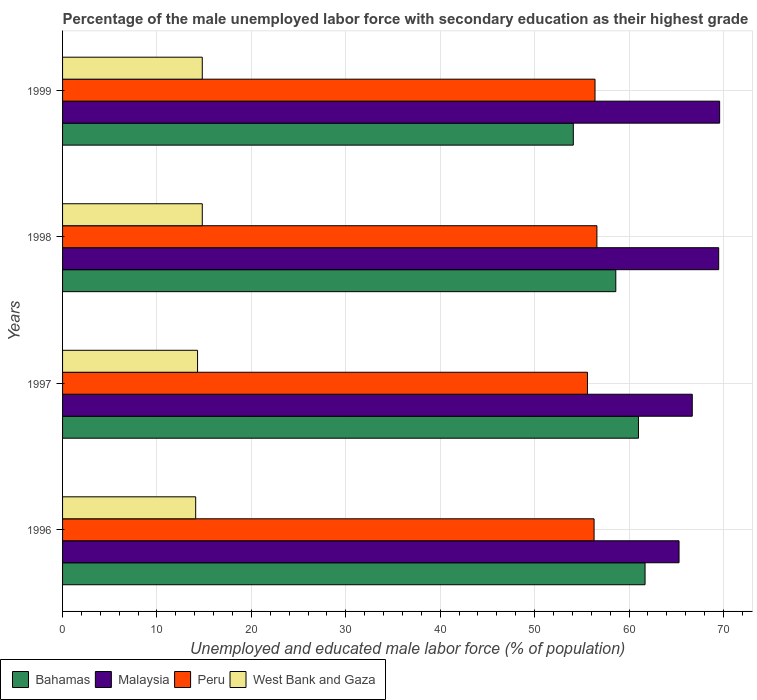How many different coloured bars are there?
Offer a terse response. 4. How many groups of bars are there?
Ensure brevity in your answer.  4. Are the number of bars per tick equal to the number of legend labels?
Your answer should be compact. Yes. Are the number of bars on each tick of the Y-axis equal?
Ensure brevity in your answer.  Yes. What is the label of the 1st group of bars from the top?
Make the answer very short. 1999. What is the percentage of the unemployed male labor force with secondary education in West Bank and Gaza in 1997?
Provide a short and direct response. 14.3. Across all years, what is the maximum percentage of the unemployed male labor force with secondary education in Bahamas?
Give a very brief answer. 61.7. Across all years, what is the minimum percentage of the unemployed male labor force with secondary education in Bahamas?
Keep it short and to the point. 54.1. What is the total percentage of the unemployed male labor force with secondary education in Bahamas in the graph?
Provide a succinct answer. 235.4. What is the difference between the percentage of the unemployed male labor force with secondary education in Malaysia in 1996 and that in 1999?
Your answer should be very brief. -4.3. What is the difference between the percentage of the unemployed male labor force with secondary education in Peru in 1996 and the percentage of the unemployed male labor force with secondary education in Bahamas in 1998?
Offer a very short reply. -2.3. What is the average percentage of the unemployed male labor force with secondary education in Malaysia per year?
Keep it short and to the point. 67.77. In the year 1996, what is the difference between the percentage of the unemployed male labor force with secondary education in Bahamas and percentage of the unemployed male labor force with secondary education in Peru?
Your answer should be very brief. 5.4. In how many years, is the percentage of the unemployed male labor force with secondary education in Malaysia greater than 66 %?
Keep it short and to the point. 3. What is the ratio of the percentage of the unemployed male labor force with secondary education in West Bank and Gaza in 1996 to that in 1998?
Provide a short and direct response. 0.95. Is the difference between the percentage of the unemployed male labor force with secondary education in Bahamas in 1996 and 1999 greater than the difference between the percentage of the unemployed male labor force with secondary education in Peru in 1996 and 1999?
Provide a succinct answer. Yes. What is the difference between the highest and the second highest percentage of the unemployed male labor force with secondary education in Bahamas?
Ensure brevity in your answer.  0.7. What is the difference between the highest and the lowest percentage of the unemployed male labor force with secondary education in Peru?
Offer a terse response. 1. In how many years, is the percentage of the unemployed male labor force with secondary education in Peru greater than the average percentage of the unemployed male labor force with secondary education in Peru taken over all years?
Your answer should be very brief. 3. Is it the case that in every year, the sum of the percentage of the unemployed male labor force with secondary education in Bahamas and percentage of the unemployed male labor force with secondary education in Peru is greater than the sum of percentage of the unemployed male labor force with secondary education in Malaysia and percentage of the unemployed male labor force with secondary education in West Bank and Gaza?
Keep it short and to the point. No. What does the 4th bar from the top in 1996 represents?
Ensure brevity in your answer.  Bahamas. What does the 4th bar from the bottom in 1999 represents?
Make the answer very short. West Bank and Gaza. How many bars are there?
Give a very brief answer. 16. Are all the bars in the graph horizontal?
Keep it short and to the point. Yes. What is the difference between two consecutive major ticks on the X-axis?
Make the answer very short. 10. Does the graph contain grids?
Your response must be concise. Yes. How many legend labels are there?
Give a very brief answer. 4. How are the legend labels stacked?
Provide a succinct answer. Horizontal. What is the title of the graph?
Provide a short and direct response. Percentage of the male unemployed labor force with secondary education as their highest grade. What is the label or title of the X-axis?
Offer a terse response. Unemployed and educated male labor force (% of population). What is the label or title of the Y-axis?
Provide a succinct answer. Years. What is the Unemployed and educated male labor force (% of population) of Bahamas in 1996?
Make the answer very short. 61.7. What is the Unemployed and educated male labor force (% of population) of Malaysia in 1996?
Offer a very short reply. 65.3. What is the Unemployed and educated male labor force (% of population) of Peru in 1996?
Provide a succinct answer. 56.3. What is the Unemployed and educated male labor force (% of population) of West Bank and Gaza in 1996?
Ensure brevity in your answer.  14.1. What is the Unemployed and educated male labor force (% of population) in Malaysia in 1997?
Keep it short and to the point. 66.7. What is the Unemployed and educated male labor force (% of population) of Peru in 1997?
Your answer should be compact. 55.6. What is the Unemployed and educated male labor force (% of population) in West Bank and Gaza in 1997?
Your answer should be compact. 14.3. What is the Unemployed and educated male labor force (% of population) in Bahamas in 1998?
Offer a terse response. 58.6. What is the Unemployed and educated male labor force (% of population) of Malaysia in 1998?
Your answer should be compact. 69.5. What is the Unemployed and educated male labor force (% of population) of Peru in 1998?
Make the answer very short. 56.6. What is the Unemployed and educated male labor force (% of population) of West Bank and Gaza in 1998?
Offer a terse response. 14.8. What is the Unemployed and educated male labor force (% of population) of Bahamas in 1999?
Provide a succinct answer. 54.1. What is the Unemployed and educated male labor force (% of population) of Malaysia in 1999?
Your answer should be compact. 69.6. What is the Unemployed and educated male labor force (% of population) in Peru in 1999?
Your answer should be very brief. 56.4. What is the Unemployed and educated male labor force (% of population) of West Bank and Gaza in 1999?
Your answer should be very brief. 14.8. Across all years, what is the maximum Unemployed and educated male labor force (% of population) of Bahamas?
Offer a very short reply. 61.7. Across all years, what is the maximum Unemployed and educated male labor force (% of population) in Malaysia?
Ensure brevity in your answer.  69.6. Across all years, what is the maximum Unemployed and educated male labor force (% of population) of Peru?
Your answer should be compact. 56.6. Across all years, what is the maximum Unemployed and educated male labor force (% of population) of West Bank and Gaza?
Your answer should be very brief. 14.8. Across all years, what is the minimum Unemployed and educated male labor force (% of population) in Bahamas?
Your answer should be compact. 54.1. Across all years, what is the minimum Unemployed and educated male labor force (% of population) in Malaysia?
Offer a very short reply. 65.3. Across all years, what is the minimum Unemployed and educated male labor force (% of population) of Peru?
Make the answer very short. 55.6. Across all years, what is the minimum Unemployed and educated male labor force (% of population) of West Bank and Gaza?
Keep it short and to the point. 14.1. What is the total Unemployed and educated male labor force (% of population) of Bahamas in the graph?
Your answer should be compact. 235.4. What is the total Unemployed and educated male labor force (% of population) of Malaysia in the graph?
Keep it short and to the point. 271.1. What is the total Unemployed and educated male labor force (% of population) of Peru in the graph?
Give a very brief answer. 224.9. What is the total Unemployed and educated male labor force (% of population) of West Bank and Gaza in the graph?
Your response must be concise. 58. What is the difference between the Unemployed and educated male labor force (% of population) in Bahamas in 1996 and that in 1997?
Provide a short and direct response. 0.7. What is the difference between the Unemployed and educated male labor force (% of population) in Malaysia in 1996 and that in 1997?
Your response must be concise. -1.4. What is the difference between the Unemployed and educated male labor force (% of population) in Peru in 1996 and that in 1997?
Offer a very short reply. 0.7. What is the difference between the Unemployed and educated male labor force (% of population) of West Bank and Gaza in 1996 and that in 1997?
Keep it short and to the point. -0.2. What is the difference between the Unemployed and educated male labor force (% of population) of Peru in 1996 and that in 1998?
Your answer should be compact. -0.3. What is the difference between the Unemployed and educated male labor force (% of population) of Bahamas in 1996 and that in 1999?
Your answer should be very brief. 7.6. What is the difference between the Unemployed and educated male labor force (% of population) of Malaysia in 1996 and that in 1999?
Your answer should be very brief. -4.3. What is the difference between the Unemployed and educated male labor force (% of population) of Malaysia in 1997 and that in 1998?
Your answer should be compact. -2.8. What is the difference between the Unemployed and educated male labor force (% of population) of Peru in 1997 and that in 1999?
Your answer should be very brief. -0.8. What is the difference between the Unemployed and educated male labor force (% of population) in Bahamas in 1998 and that in 1999?
Offer a very short reply. 4.5. What is the difference between the Unemployed and educated male labor force (% of population) of Peru in 1998 and that in 1999?
Provide a succinct answer. 0.2. What is the difference between the Unemployed and educated male labor force (% of population) in West Bank and Gaza in 1998 and that in 1999?
Keep it short and to the point. 0. What is the difference between the Unemployed and educated male labor force (% of population) of Bahamas in 1996 and the Unemployed and educated male labor force (% of population) of Malaysia in 1997?
Offer a very short reply. -5. What is the difference between the Unemployed and educated male labor force (% of population) in Bahamas in 1996 and the Unemployed and educated male labor force (% of population) in Peru in 1997?
Give a very brief answer. 6.1. What is the difference between the Unemployed and educated male labor force (% of population) of Bahamas in 1996 and the Unemployed and educated male labor force (% of population) of West Bank and Gaza in 1997?
Make the answer very short. 47.4. What is the difference between the Unemployed and educated male labor force (% of population) of Malaysia in 1996 and the Unemployed and educated male labor force (% of population) of Peru in 1997?
Provide a short and direct response. 9.7. What is the difference between the Unemployed and educated male labor force (% of population) in Bahamas in 1996 and the Unemployed and educated male labor force (% of population) in Malaysia in 1998?
Your answer should be very brief. -7.8. What is the difference between the Unemployed and educated male labor force (% of population) of Bahamas in 1996 and the Unemployed and educated male labor force (% of population) of Peru in 1998?
Give a very brief answer. 5.1. What is the difference between the Unemployed and educated male labor force (% of population) in Bahamas in 1996 and the Unemployed and educated male labor force (% of population) in West Bank and Gaza in 1998?
Keep it short and to the point. 46.9. What is the difference between the Unemployed and educated male labor force (% of population) in Malaysia in 1996 and the Unemployed and educated male labor force (% of population) in Peru in 1998?
Give a very brief answer. 8.7. What is the difference between the Unemployed and educated male labor force (% of population) of Malaysia in 1996 and the Unemployed and educated male labor force (% of population) of West Bank and Gaza in 1998?
Your answer should be compact. 50.5. What is the difference between the Unemployed and educated male labor force (% of population) of Peru in 1996 and the Unemployed and educated male labor force (% of population) of West Bank and Gaza in 1998?
Keep it short and to the point. 41.5. What is the difference between the Unemployed and educated male labor force (% of population) of Bahamas in 1996 and the Unemployed and educated male labor force (% of population) of Peru in 1999?
Make the answer very short. 5.3. What is the difference between the Unemployed and educated male labor force (% of population) of Bahamas in 1996 and the Unemployed and educated male labor force (% of population) of West Bank and Gaza in 1999?
Keep it short and to the point. 46.9. What is the difference between the Unemployed and educated male labor force (% of population) in Malaysia in 1996 and the Unemployed and educated male labor force (% of population) in West Bank and Gaza in 1999?
Your answer should be compact. 50.5. What is the difference between the Unemployed and educated male labor force (% of population) of Peru in 1996 and the Unemployed and educated male labor force (% of population) of West Bank and Gaza in 1999?
Provide a succinct answer. 41.5. What is the difference between the Unemployed and educated male labor force (% of population) of Bahamas in 1997 and the Unemployed and educated male labor force (% of population) of Peru in 1998?
Ensure brevity in your answer.  4.4. What is the difference between the Unemployed and educated male labor force (% of population) in Bahamas in 1997 and the Unemployed and educated male labor force (% of population) in West Bank and Gaza in 1998?
Provide a short and direct response. 46.2. What is the difference between the Unemployed and educated male labor force (% of population) of Malaysia in 1997 and the Unemployed and educated male labor force (% of population) of Peru in 1998?
Your answer should be compact. 10.1. What is the difference between the Unemployed and educated male labor force (% of population) of Malaysia in 1997 and the Unemployed and educated male labor force (% of population) of West Bank and Gaza in 1998?
Provide a succinct answer. 51.9. What is the difference between the Unemployed and educated male labor force (% of population) of Peru in 1997 and the Unemployed and educated male labor force (% of population) of West Bank and Gaza in 1998?
Your answer should be very brief. 40.8. What is the difference between the Unemployed and educated male labor force (% of population) in Bahamas in 1997 and the Unemployed and educated male labor force (% of population) in West Bank and Gaza in 1999?
Your response must be concise. 46.2. What is the difference between the Unemployed and educated male labor force (% of population) of Malaysia in 1997 and the Unemployed and educated male labor force (% of population) of West Bank and Gaza in 1999?
Your answer should be compact. 51.9. What is the difference between the Unemployed and educated male labor force (% of population) in Peru in 1997 and the Unemployed and educated male labor force (% of population) in West Bank and Gaza in 1999?
Provide a short and direct response. 40.8. What is the difference between the Unemployed and educated male labor force (% of population) of Bahamas in 1998 and the Unemployed and educated male labor force (% of population) of Peru in 1999?
Provide a short and direct response. 2.2. What is the difference between the Unemployed and educated male labor force (% of population) of Bahamas in 1998 and the Unemployed and educated male labor force (% of population) of West Bank and Gaza in 1999?
Make the answer very short. 43.8. What is the difference between the Unemployed and educated male labor force (% of population) in Malaysia in 1998 and the Unemployed and educated male labor force (% of population) in West Bank and Gaza in 1999?
Your answer should be very brief. 54.7. What is the difference between the Unemployed and educated male labor force (% of population) in Peru in 1998 and the Unemployed and educated male labor force (% of population) in West Bank and Gaza in 1999?
Offer a very short reply. 41.8. What is the average Unemployed and educated male labor force (% of population) of Bahamas per year?
Provide a succinct answer. 58.85. What is the average Unemployed and educated male labor force (% of population) of Malaysia per year?
Provide a succinct answer. 67.78. What is the average Unemployed and educated male labor force (% of population) in Peru per year?
Provide a succinct answer. 56.23. In the year 1996, what is the difference between the Unemployed and educated male labor force (% of population) in Bahamas and Unemployed and educated male labor force (% of population) in Malaysia?
Make the answer very short. -3.6. In the year 1996, what is the difference between the Unemployed and educated male labor force (% of population) of Bahamas and Unemployed and educated male labor force (% of population) of Peru?
Ensure brevity in your answer.  5.4. In the year 1996, what is the difference between the Unemployed and educated male labor force (% of population) of Bahamas and Unemployed and educated male labor force (% of population) of West Bank and Gaza?
Make the answer very short. 47.6. In the year 1996, what is the difference between the Unemployed and educated male labor force (% of population) in Malaysia and Unemployed and educated male labor force (% of population) in West Bank and Gaza?
Ensure brevity in your answer.  51.2. In the year 1996, what is the difference between the Unemployed and educated male labor force (% of population) in Peru and Unemployed and educated male labor force (% of population) in West Bank and Gaza?
Offer a very short reply. 42.2. In the year 1997, what is the difference between the Unemployed and educated male labor force (% of population) in Bahamas and Unemployed and educated male labor force (% of population) in Malaysia?
Your answer should be compact. -5.7. In the year 1997, what is the difference between the Unemployed and educated male labor force (% of population) in Bahamas and Unemployed and educated male labor force (% of population) in West Bank and Gaza?
Make the answer very short. 46.7. In the year 1997, what is the difference between the Unemployed and educated male labor force (% of population) in Malaysia and Unemployed and educated male labor force (% of population) in Peru?
Offer a very short reply. 11.1. In the year 1997, what is the difference between the Unemployed and educated male labor force (% of population) in Malaysia and Unemployed and educated male labor force (% of population) in West Bank and Gaza?
Give a very brief answer. 52.4. In the year 1997, what is the difference between the Unemployed and educated male labor force (% of population) of Peru and Unemployed and educated male labor force (% of population) of West Bank and Gaza?
Offer a terse response. 41.3. In the year 1998, what is the difference between the Unemployed and educated male labor force (% of population) in Bahamas and Unemployed and educated male labor force (% of population) in Malaysia?
Give a very brief answer. -10.9. In the year 1998, what is the difference between the Unemployed and educated male labor force (% of population) of Bahamas and Unemployed and educated male labor force (% of population) of West Bank and Gaza?
Provide a succinct answer. 43.8. In the year 1998, what is the difference between the Unemployed and educated male labor force (% of population) in Malaysia and Unemployed and educated male labor force (% of population) in Peru?
Your answer should be compact. 12.9. In the year 1998, what is the difference between the Unemployed and educated male labor force (% of population) in Malaysia and Unemployed and educated male labor force (% of population) in West Bank and Gaza?
Your answer should be compact. 54.7. In the year 1998, what is the difference between the Unemployed and educated male labor force (% of population) of Peru and Unemployed and educated male labor force (% of population) of West Bank and Gaza?
Your answer should be compact. 41.8. In the year 1999, what is the difference between the Unemployed and educated male labor force (% of population) in Bahamas and Unemployed and educated male labor force (% of population) in Malaysia?
Provide a short and direct response. -15.5. In the year 1999, what is the difference between the Unemployed and educated male labor force (% of population) of Bahamas and Unemployed and educated male labor force (% of population) of West Bank and Gaza?
Ensure brevity in your answer.  39.3. In the year 1999, what is the difference between the Unemployed and educated male labor force (% of population) in Malaysia and Unemployed and educated male labor force (% of population) in West Bank and Gaza?
Keep it short and to the point. 54.8. In the year 1999, what is the difference between the Unemployed and educated male labor force (% of population) of Peru and Unemployed and educated male labor force (% of population) of West Bank and Gaza?
Your answer should be compact. 41.6. What is the ratio of the Unemployed and educated male labor force (% of population) in Bahamas in 1996 to that in 1997?
Your response must be concise. 1.01. What is the ratio of the Unemployed and educated male labor force (% of population) of Peru in 1996 to that in 1997?
Provide a short and direct response. 1.01. What is the ratio of the Unemployed and educated male labor force (% of population) in Bahamas in 1996 to that in 1998?
Your answer should be very brief. 1.05. What is the ratio of the Unemployed and educated male labor force (% of population) in Malaysia in 1996 to that in 1998?
Make the answer very short. 0.94. What is the ratio of the Unemployed and educated male labor force (% of population) in West Bank and Gaza in 1996 to that in 1998?
Provide a short and direct response. 0.95. What is the ratio of the Unemployed and educated male labor force (% of population) of Bahamas in 1996 to that in 1999?
Provide a succinct answer. 1.14. What is the ratio of the Unemployed and educated male labor force (% of population) of Malaysia in 1996 to that in 1999?
Offer a terse response. 0.94. What is the ratio of the Unemployed and educated male labor force (% of population) of Peru in 1996 to that in 1999?
Ensure brevity in your answer.  1. What is the ratio of the Unemployed and educated male labor force (% of population) in West Bank and Gaza in 1996 to that in 1999?
Keep it short and to the point. 0.95. What is the ratio of the Unemployed and educated male labor force (% of population) in Bahamas in 1997 to that in 1998?
Offer a very short reply. 1.04. What is the ratio of the Unemployed and educated male labor force (% of population) of Malaysia in 1997 to that in 1998?
Offer a terse response. 0.96. What is the ratio of the Unemployed and educated male labor force (% of population) in Peru in 1997 to that in 1998?
Keep it short and to the point. 0.98. What is the ratio of the Unemployed and educated male labor force (% of population) in West Bank and Gaza in 1997 to that in 1998?
Offer a very short reply. 0.97. What is the ratio of the Unemployed and educated male labor force (% of population) in Bahamas in 1997 to that in 1999?
Your answer should be compact. 1.13. What is the ratio of the Unemployed and educated male labor force (% of population) of Peru in 1997 to that in 1999?
Ensure brevity in your answer.  0.99. What is the ratio of the Unemployed and educated male labor force (% of population) of West Bank and Gaza in 1997 to that in 1999?
Your response must be concise. 0.97. What is the ratio of the Unemployed and educated male labor force (% of population) in Bahamas in 1998 to that in 1999?
Your answer should be very brief. 1.08. What is the ratio of the Unemployed and educated male labor force (% of population) in Malaysia in 1998 to that in 1999?
Ensure brevity in your answer.  1. What is the ratio of the Unemployed and educated male labor force (% of population) in Peru in 1998 to that in 1999?
Make the answer very short. 1. What is the difference between the highest and the second highest Unemployed and educated male labor force (% of population) in Peru?
Your answer should be compact. 0.2. What is the difference between the highest and the second highest Unemployed and educated male labor force (% of population) of West Bank and Gaza?
Your answer should be very brief. 0. What is the difference between the highest and the lowest Unemployed and educated male labor force (% of population) in Bahamas?
Give a very brief answer. 7.6. What is the difference between the highest and the lowest Unemployed and educated male labor force (% of population) of West Bank and Gaza?
Give a very brief answer. 0.7. 